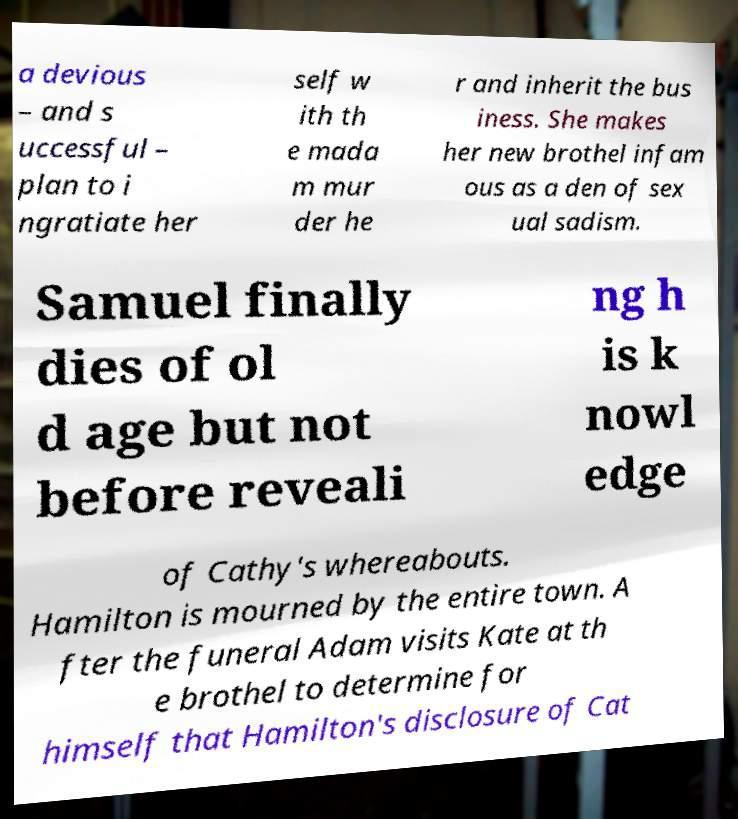I need the written content from this picture converted into text. Can you do that? a devious – and s uccessful – plan to i ngratiate her self w ith th e mada m mur der he r and inherit the bus iness. She makes her new brothel infam ous as a den of sex ual sadism. Samuel finally dies of ol d age but not before reveali ng h is k nowl edge of Cathy's whereabouts. Hamilton is mourned by the entire town. A fter the funeral Adam visits Kate at th e brothel to determine for himself that Hamilton's disclosure of Cat 